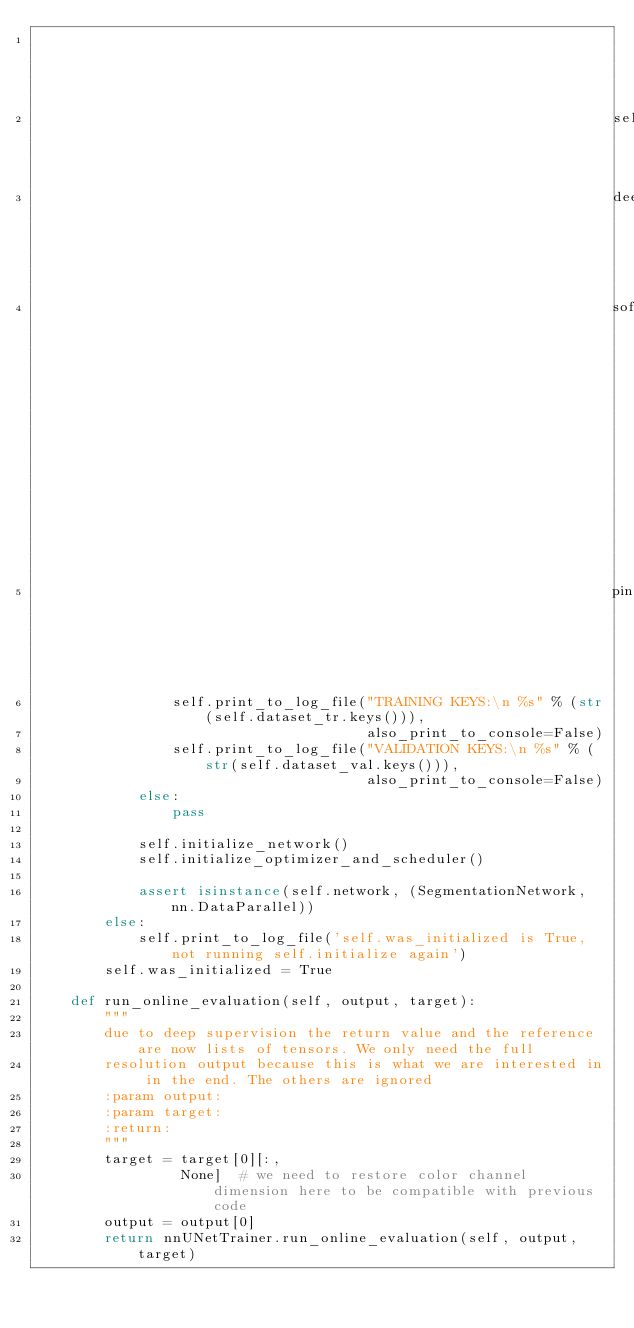Convert code to text. <code><loc_0><loc_0><loc_500><loc_500><_Python_>                                                                        'patch_size_for_spatialtransform'],
                                                                    self.data_aug_params,
                                                                    deep_supervision_scales=self.deep_supervision_scales,
                                                                    soft_ds=True, classes=[0] + list(self.classes),
                                                                    pin_memory=self.pin_memory)
                self.print_to_log_file("TRAINING KEYS:\n %s" % (str(self.dataset_tr.keys())),
                                       also_print_to_console=False)
                self.print_to_log_file("VALIDATION KEYS:\n %s" % (str(self.dataset_val.keys())),
                                       also_print_to_console=False)
            else:
                pass

            self.initialize_network()
            self.initialize_optimizer_and_scheduler()

            assert isinstance(self.network, (SegmentationNetwork, nn.DataParallel))
        else:
            self.print_to_log_file('self.was_initialized is True, not running self.initialize again')
        self.was_initialized = True

    def run_online_evaluation(self, output, target):
        """
        due to deep supervision the return value and the reference are now lists of tensors. We only need the full
        resolution output because this is what we are interested in in the end. The others are ignored
        :param output:
        :param target:
        :return:
        """
        target = target[0][:,
                 None]  # we need to restore color channel dimension here to be compatible with previous code
        output = output[0]
        return nnUNetTrainer.run_online_evaluation(self, output, target)
</code> 